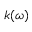<formula> <loc_0><loc_0><loc_500><loc_500>k ( \omega )</formula> 